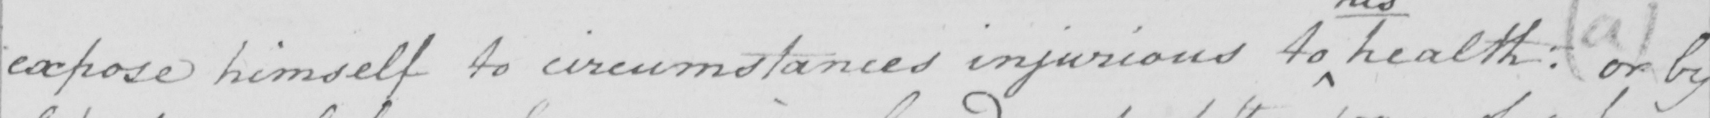Can you tell me what this handwritten text says? expose himself to circumstances injurious to health :  or by 